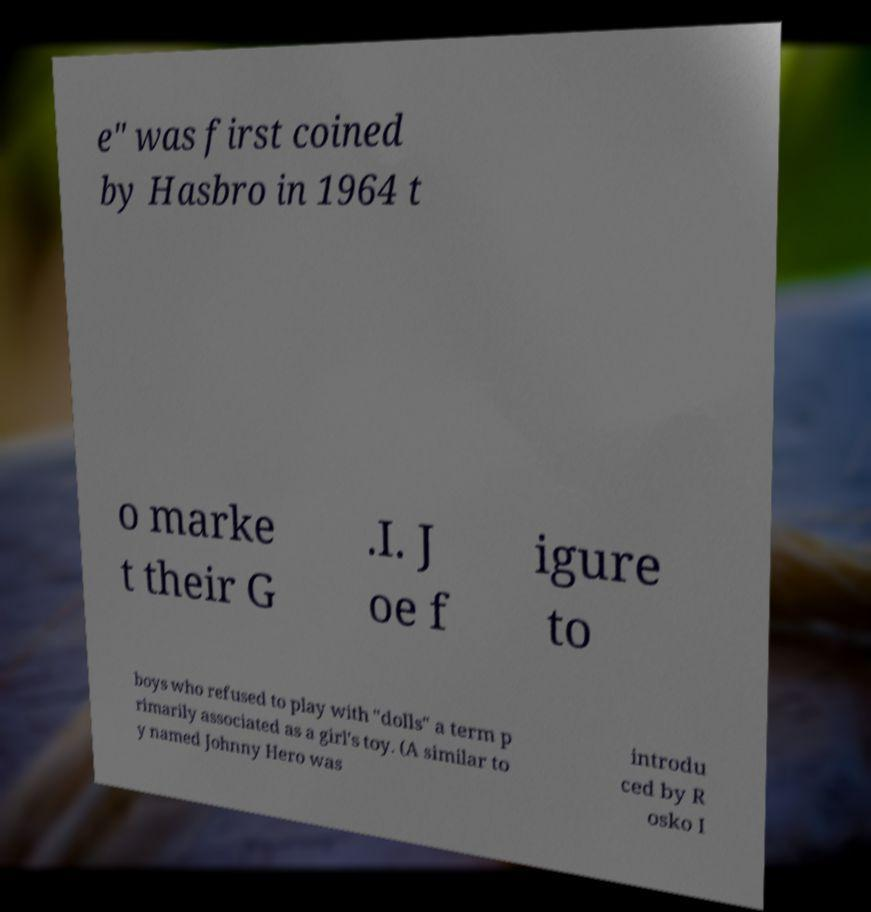Please identify and transcribe the text found in this image. e" was first coined by Hasbro in 1964 t o marke t their G .I. J oe f igure to boys who refused to play with "dolls" a term p rimarily associated as a girl's toy. (A similar to y named Johnny Hero was introdu ced by R osko I 